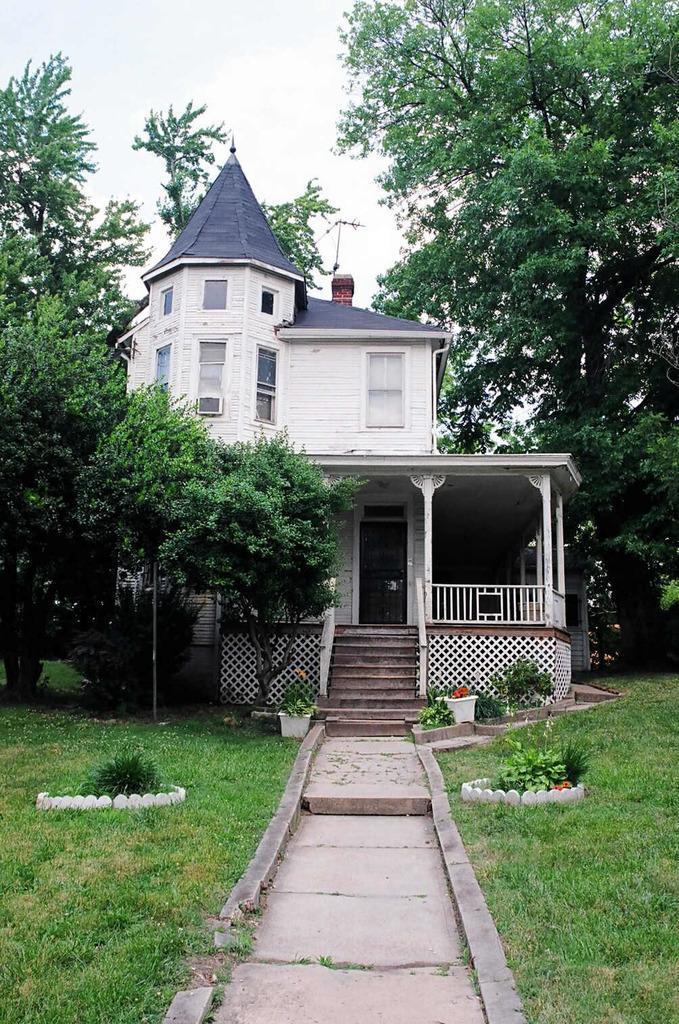Describe this image in one or two sentences. In this picture I can see a house, trees, grass and path. 